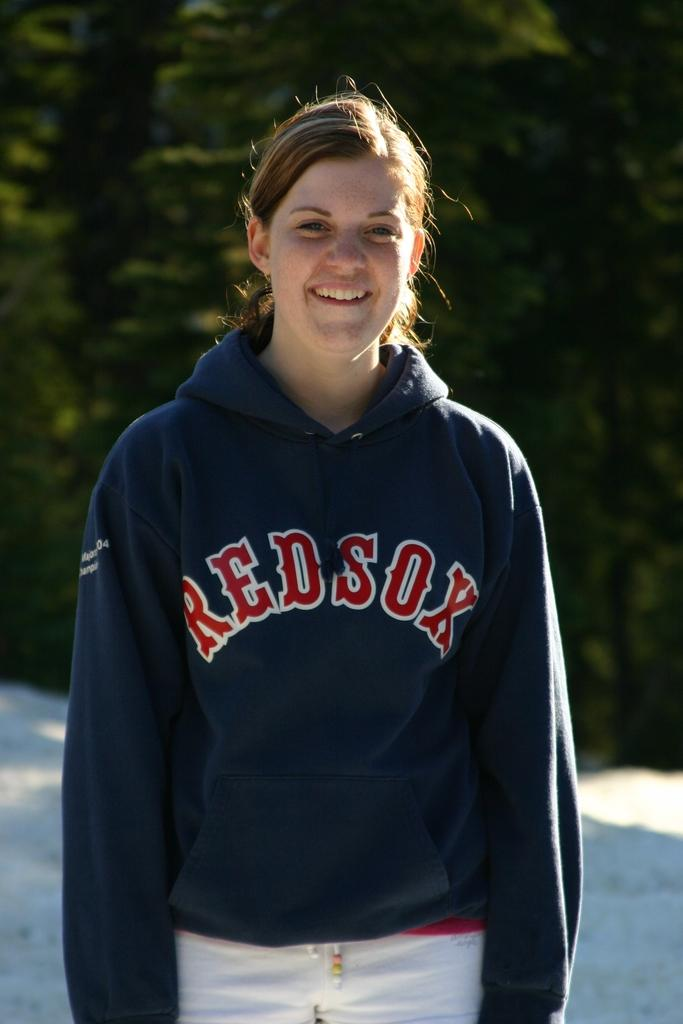Who is the main subject in the image? There is a lady in the image. What is the lady doing in the image? The lady is standing and posing for a picture. What can be seen in the background of the image? There are trees visible in the background of the image. Can you see a donkey in the image? No, there is no donkey present in the image. What type of liquid is being used to create the pose in the image? There is no liquid involved in the lady's pose in the image. 